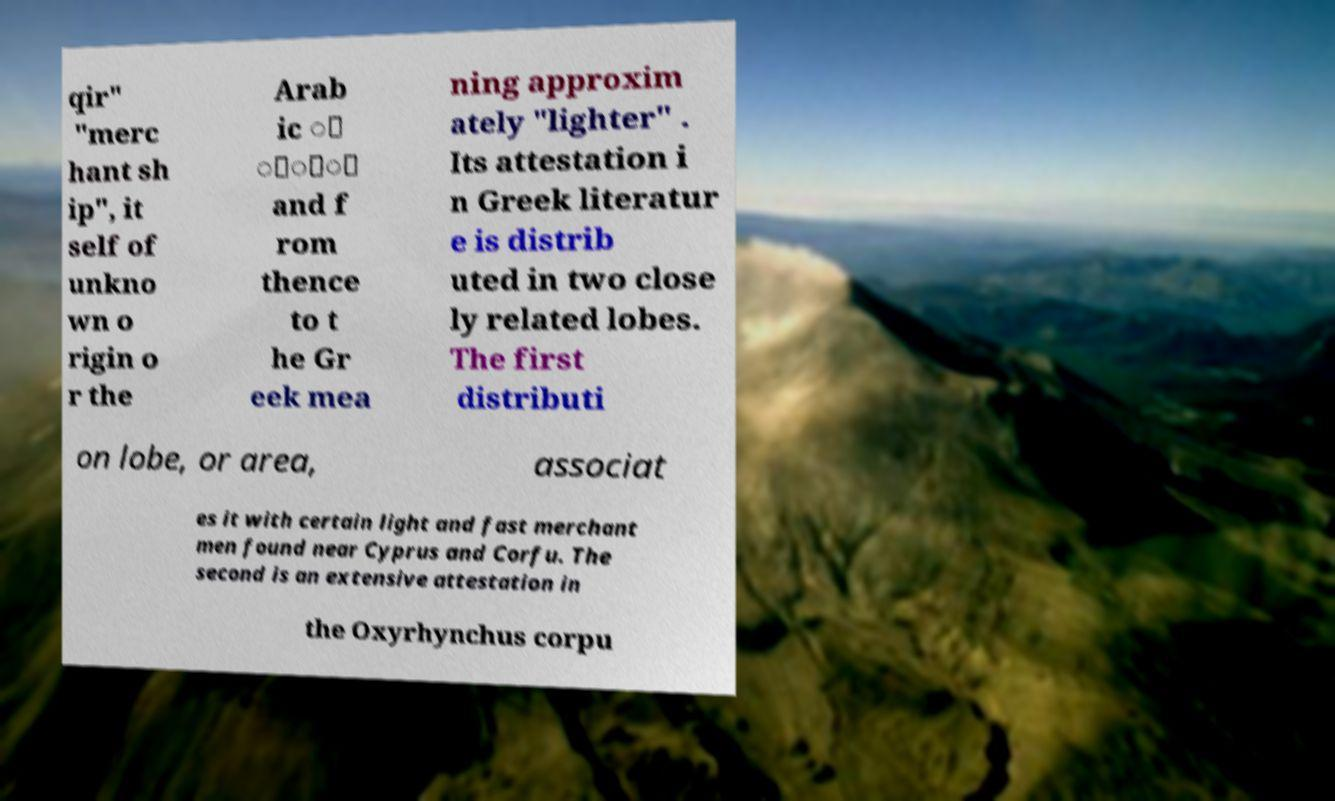Could you assist in decoding the text presented in this image and type it out clearly? qir" "merc hant sh ip", it self of unkno wn o rigin o r the Arab ic ُ ُُْ and f rom thence to t he Gr eek mea ning approxim ately "lighter" . Its attestation i n Greek literatur e is distrib uted in two close ly related lobes. The first distributi on lobe, or area, associat es it with certain light and fast merchant men found near Cyprus and Corfu. The second is an extensive attestation in the Oxyrhynchus corpu 